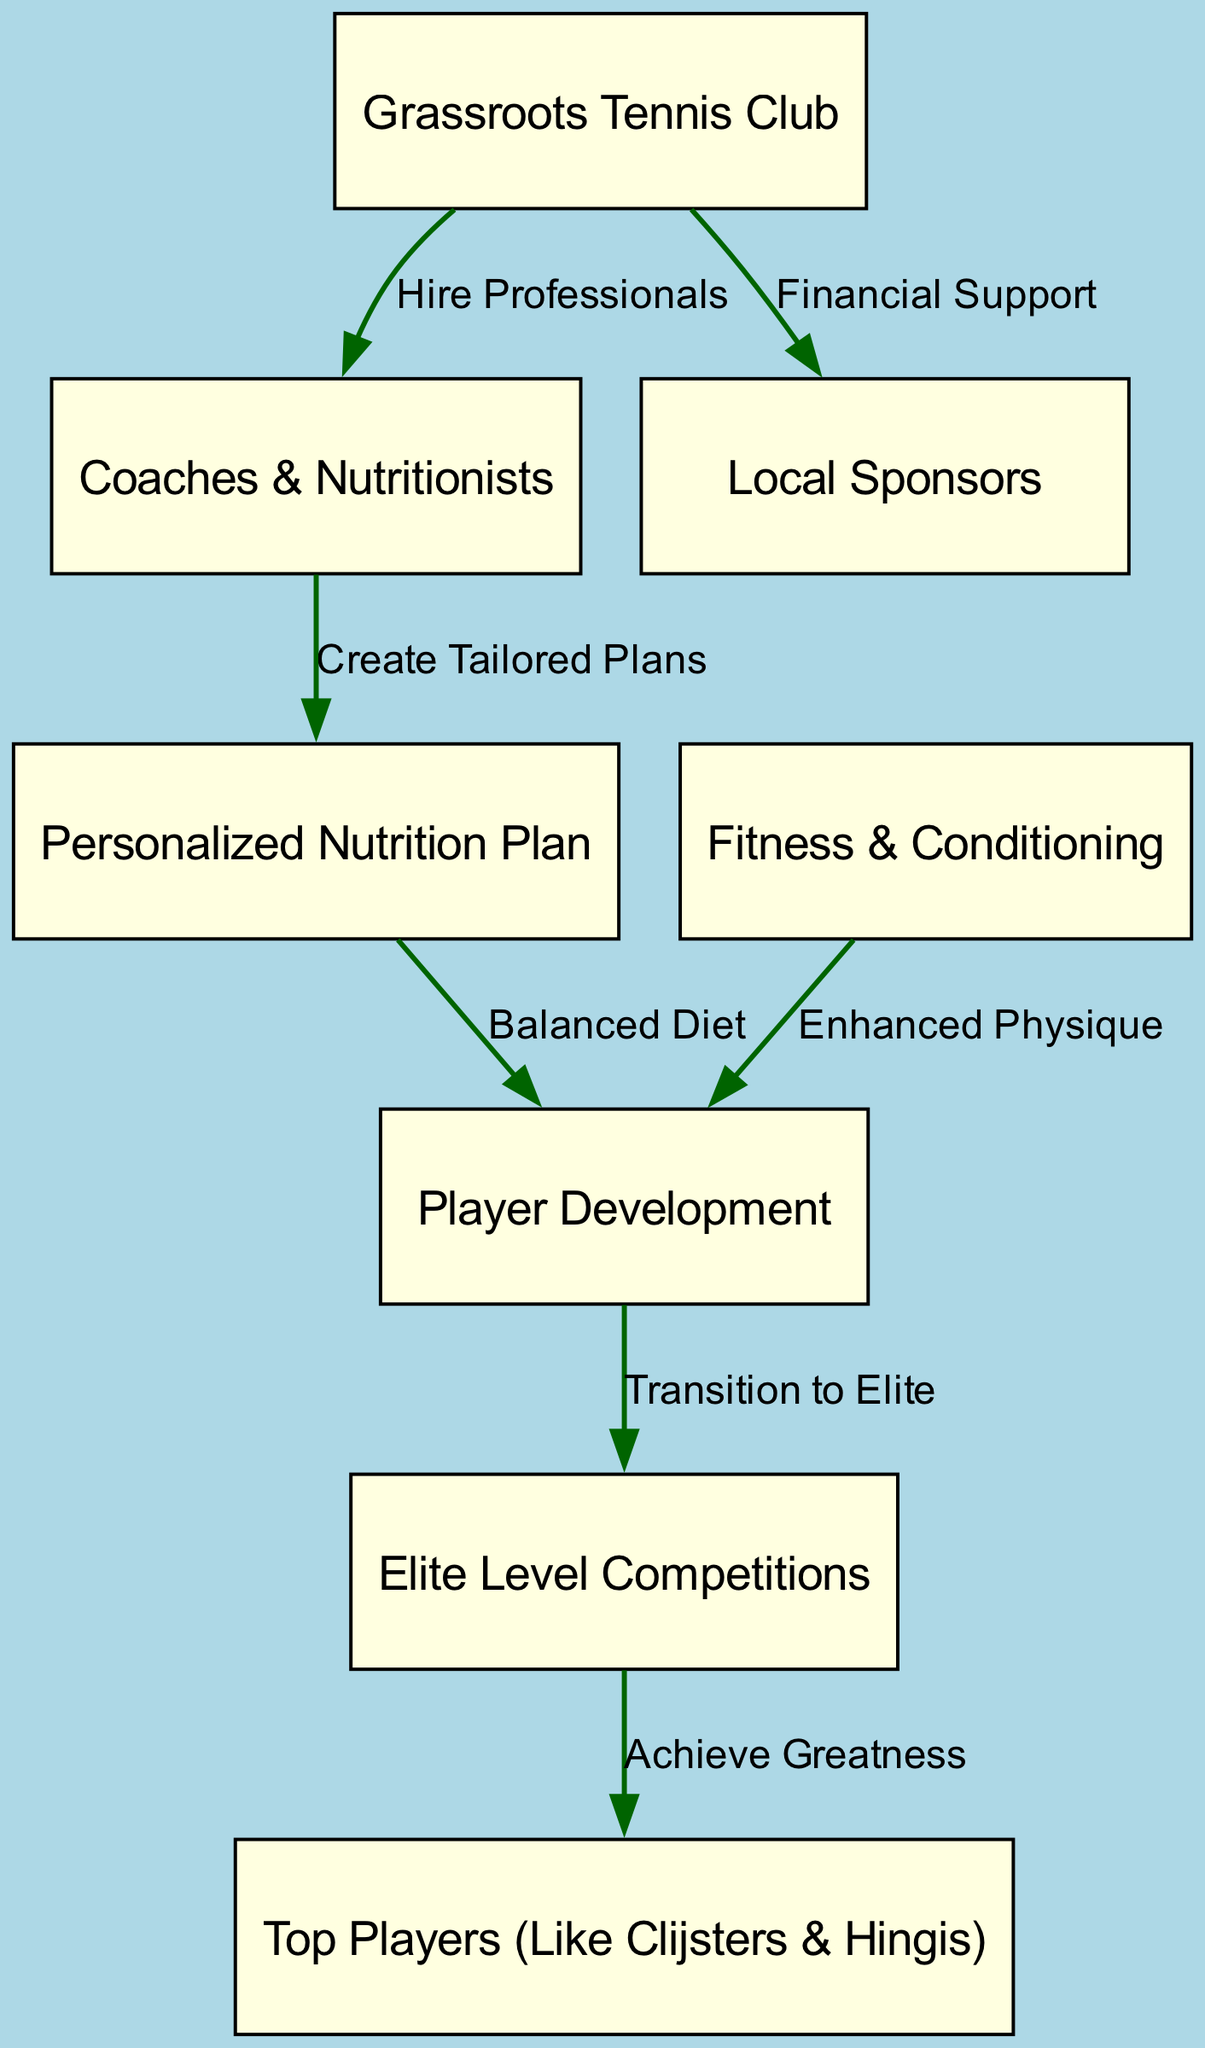What is the starting point of the food energy transfer? The starting point is represented by the node "Grassroots Tennis Club". This is where the process of supporting young players begins.
Answer: Grassroots Tennis Club How many nodes are present in the diagram? The diagram presents a total of 8 nodes, which include all key components of the food energy transfer process.
Answer: 8 What type of support do grassroots clubs provide to local sponsors? Grassroots clubs provide "Financial Support" to local sponsors, creating a connection between the two nodes.
Answer: Financial Support What is created by coaches and nutritionists? Coaches and nutritionists "Create Tailored Plans", which is a critical part of developing young players’ nutrition.
Answer: Create Tailored Plans What is the final output node in the energy transfer chain? The final output node, which represents the ultimate achievement in the chain, is "Top Players (Like Clijsters & Hingis)".
Answer: Top Players (Like Clijsters & Hingis) What follows the personalized nutrition plan in the transfer process? The "Balanced Diet" that results from the personalized nutrition plan leads directly to "Player Development". This shows the sequence of effects following nutritional planning.
Answer: Balanced Diet Which node is involved in transitioning players to elite competitions? The node "Player Development" is the one that facilitates the transition to "Elite Level Competitions", emphasizing its role in the progress of young tennis players.
Answer: Player Development How do grassroots clubs contribute to player development? Grassroots clubs contribute by hiring professionals, such as coaches, who are critical for the training and development of players.
Answer: Hire Professionals What label connects nutrition plans to player development? The edge connecting these two nodes is labeled "Balanced Diet", indicating the importance of nutrition in the player's growth and skills enhancement.
Answer: Balanced Diet 